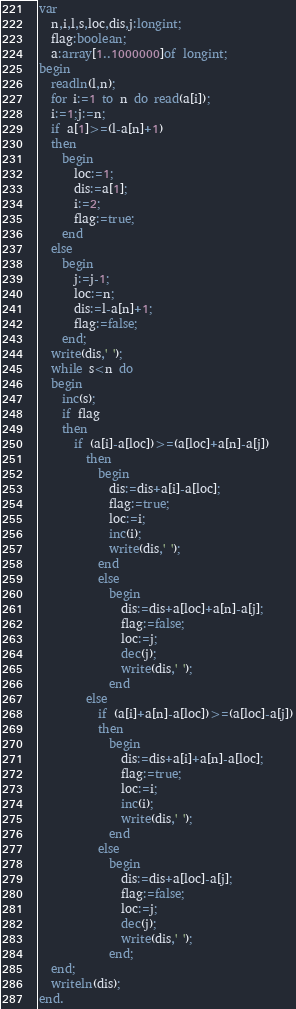Convert code to text. <code><loc_0><loc_0><loc_500><loc_500><_Pascal_>var
  n,i,l,s,loc,dis,j:longint;
  flag:boolean;
  a:array[1..1000000]of longint;
begin
  readln(l,n);
  for i:=1 to n do read(a[i]);
  i:=1;j:=n;
  if a[1]>=(l-a[n]+1) 
  then 
    begin 
	  loc:=1;
	  dis:=a[1];
	  i:=2;
	  flag:=true;
	end 
  else 
    begin 
      j:=j-1;
	  loc:=n;
	  dis:=l-a[n]+1;
	  flag:=false;
	end;
  write(dis,' ');
  while s<n do
  begin
    inc(s);
	if flag 
	then
	  if (a[i]-a[loc])>=(a[loc]+a[n]-a[j])
	    then 
		  begin 
			dis:=dis+a[i]-a[loc];
			flag:=true;
			loc:=i;
			inc(i);
			write(dis,' ');
	      end
		  else
		    begin
			  dis:=dis+a[loc]+a[n]-a[j];
			  flag:=false;
			  loc:=j;
			  dec(j);
			  write(dis,' ');
			end
		else
		  if (a[i]+a[n]-a[loc])>=(a[loc]-a[j])
		  then
			begin 
			  dis:=dis+a[i]+a[n]-a[loc];
			  flag:=true;
			  loc:=i;
			  inc(i);
			  write(dis,' ');
	        end
		  else 
		    begin
			  dis:=dis+a[loc]-a[j];
			  flag:=false;
			  loc:=j;
			  dec(j);
			  write(dis,' ');
			end;
  end;
  writeln(dis);
end.</code> 